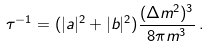<formula> <loc_0><loc_0><loc_500><loc_500>\tau ^ { - 1 } = ( | a | ^ { 2 } + | b | ^ { 2 } ) \frac { ( \Delta m ^ { 2 } ) ^ { 3 } } { 8 \pi m ^ { 3 } } \, .</formula> 